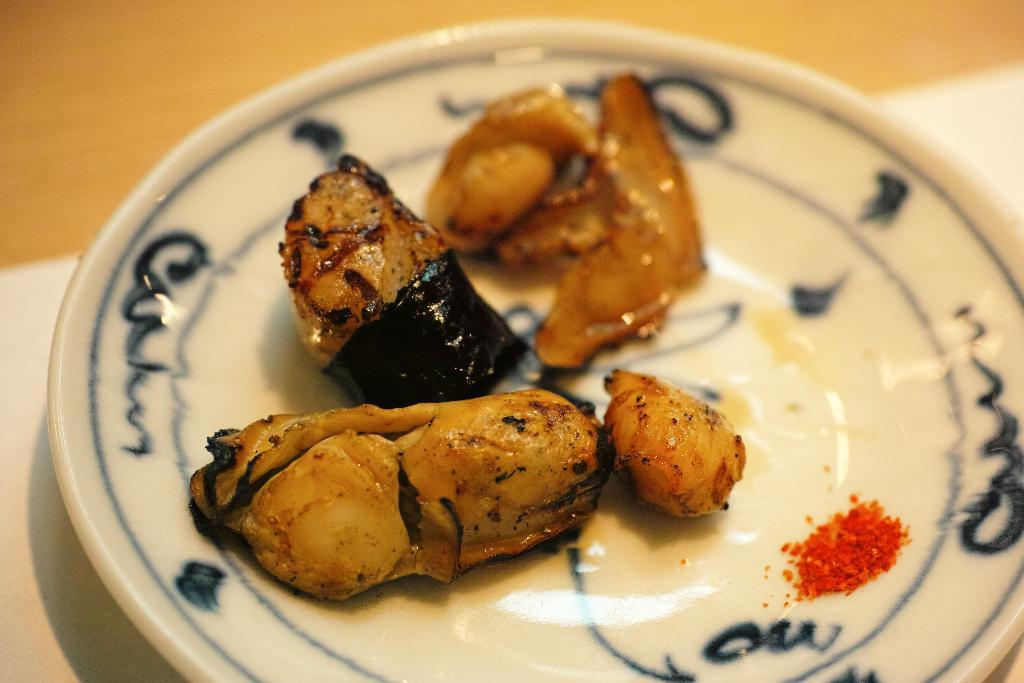What is present on the plate in the image? There are food items on a white color plate in the image. Can you describe the color of the plate? The plate is white in color. What type of beast is shown expressing hate towards the food items in the image? There is no beast present in the image, nor is there any expression of hate towards the food items. 